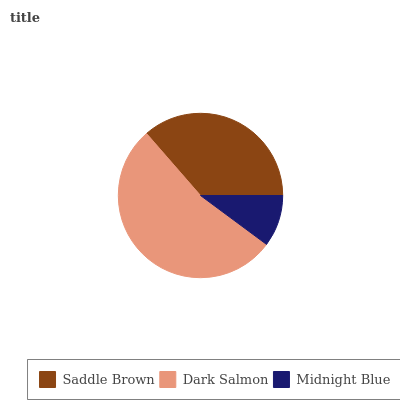Is Midnight Blue the minimum?
Answer yes or no. Yes. Is Dark Salmon the maximum?
Answer yes or no. Yes. Is Dark Salmon the minimum?
Answer yes or no. No. Is Midnight Blue the maximum?
Answer yes or no. No. Is Dark Salmon greater than Midnight Blue?
Answer yes or no. Yes. Is Midnight Blue less than Dark Salmon?
Answer yes or no. Yes. Is Midnight Blue greater than Dark Salmon?
Answer yes or no. No. Is Dark Salmon less than Midnight Blue?
Answer yes or no. No. Is Saddle Brown the high median?
Answer yes or no. Yes. Is Saddle Brown the low median?
Answer yes or no. Yes. Is Dark Salmon the high median?
Answer yes or no. No. Is Dark Salmon the low median?
Answer yes or no. No. 